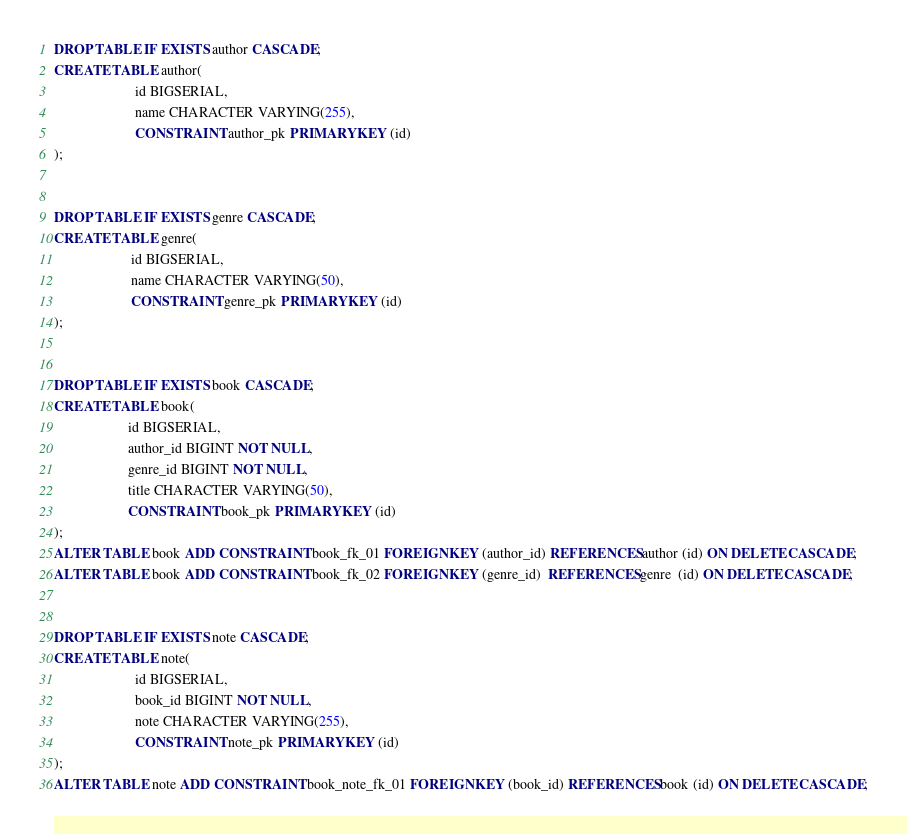Convert code to text. <code><loc_0><loc_0><loc_500><loc_500><_SQL_>DROP TABLE IF EXISTS author CASCADE;
CREATE TABLE author(
                       id BIGSERIAL,
                       name CHARACTER VARYING(255),
                       CONSTRAINT author_pk PRIMARY KEY (id)
);


DROP TABLE IF EXISTS genre CASCADE;
CREATE TABLE genre(
                      id BIGSERIAL,
                      name CHARACTER VARYING(50),
                      CONSTRAINT genre_pk PRIMARY KEY (id)
);


DROP TABLE IF EXISTS book CASCADE;
CREATE TABLE book(
                     id BIGSERIAL,
                     author_id BIGINT NOT NULL,
                     genre_id BIGINT NOT NULL,
                     title CHARACTER VARYING(50),
                     CONSTRAINT book_pk PRIMARY KEY (id)
);
ALTER TABLE book ADD CONSTRAINT book_fk_01 FOREIGN KEY (author_id) REFERENCES author (id) ON DELETE CASCADE;
ALTER TABLE book ADD CONSTRAINT book_fk_02 FOREIGN KEY (genre_id)  REFERENCES genre  (id) ON DELETE CASCADE;


DROP TABLE IF EXISTS note CASCADE;
CREATE TABLE note(
                       id BIGSERIAL,
                       book_id BIGINT NOT NULL,
                       note CHARACTER VARYING(255),
                       CONSTRAINT note_pk PRIMARY KEY (id)
);
ALTER TABLE note ADD CONSTRAINT book_note_fk_01 FOREIGN KEY (book_id) REFERENCES book (id) ON DELETE CASCADE;
</code> 